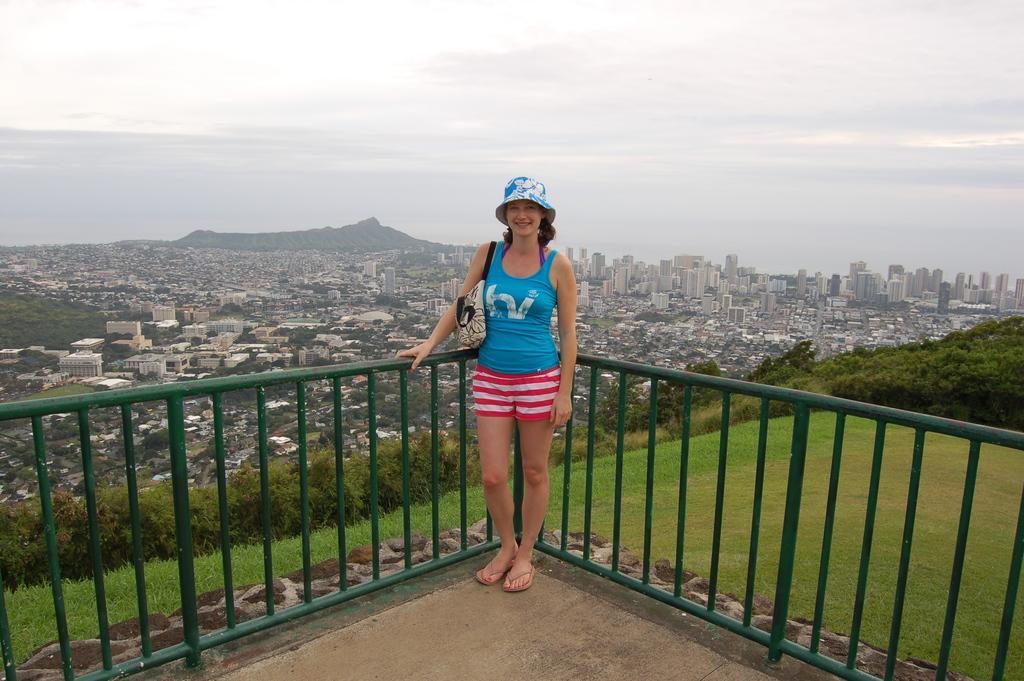Describe this image in one or two sentences. This picture is clicked outside. In the foreground we can see a woman wearing t-shirt, sling bag, hat, smiling and standing on the floor and we can see the railing, green grass and plants. In the background we can see the sky, hills, buildings, skyscrapers, trees and many other objects. 